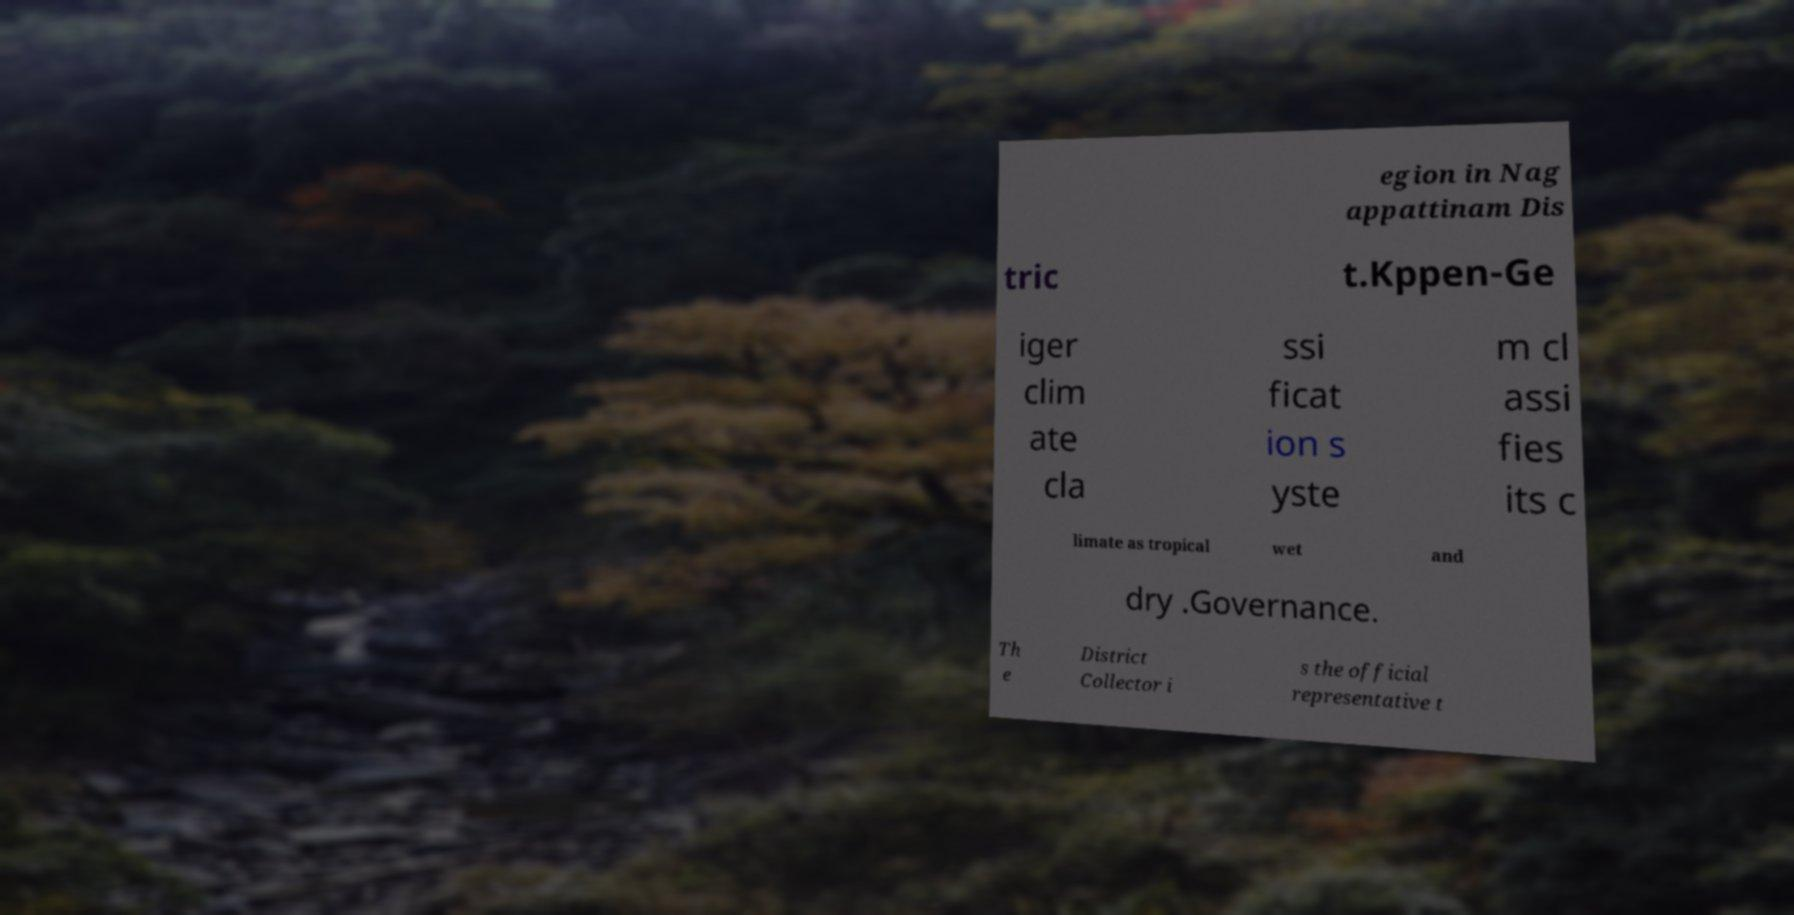Can you read and provide the text displayed in the image?This photo seems to have some interesting text. Can you extract and type it out for me? egion in Nag appattinam Dis tric t.Kppen-Ge iger clim ate cla ssi ficat ion s yste m cl assi fies its c limate as tropical wet and dry .Governance. Th e District Collector i s the official representative t 